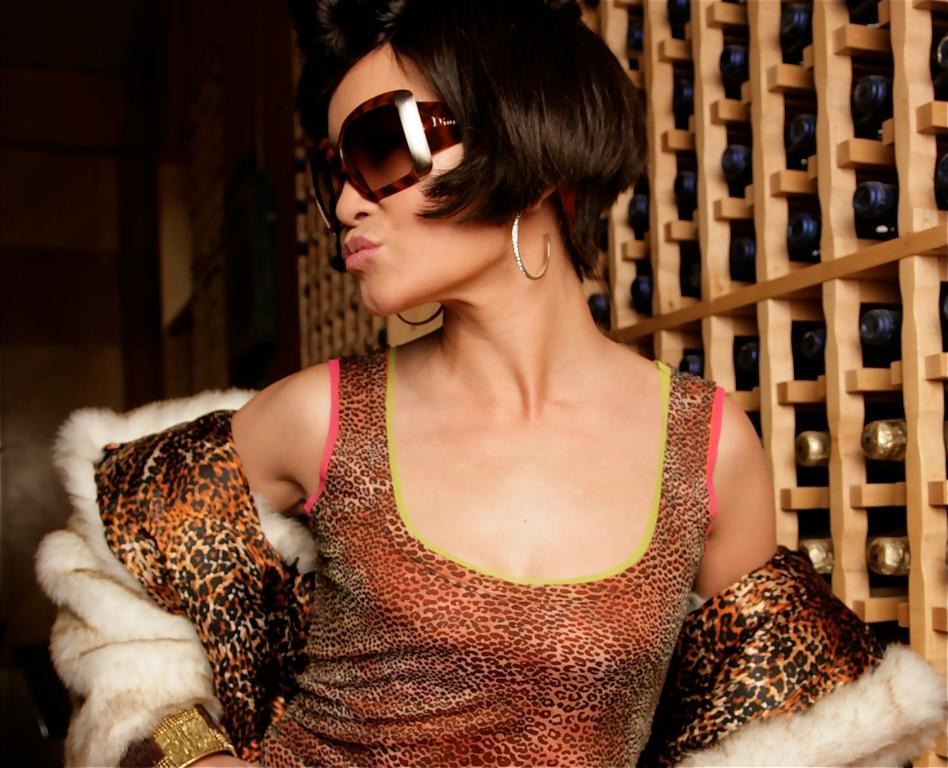Who is the main subject in the image? There is a lady in the image. What is the lady wearing on her face? The lady is wearing goggles. How would you describe the lady's hairstyle? The lady has short hair. What can be seen on the right side of the image? There are bottles on the right side of the image. What type of gun is the lady holding in the image? There is no gun present in the image; the lady is wearing goggles and has short hair. What statement does the lady make in the image? The image does not include any text or dialogue, so it is not possible to determine what statement the lady might make. 